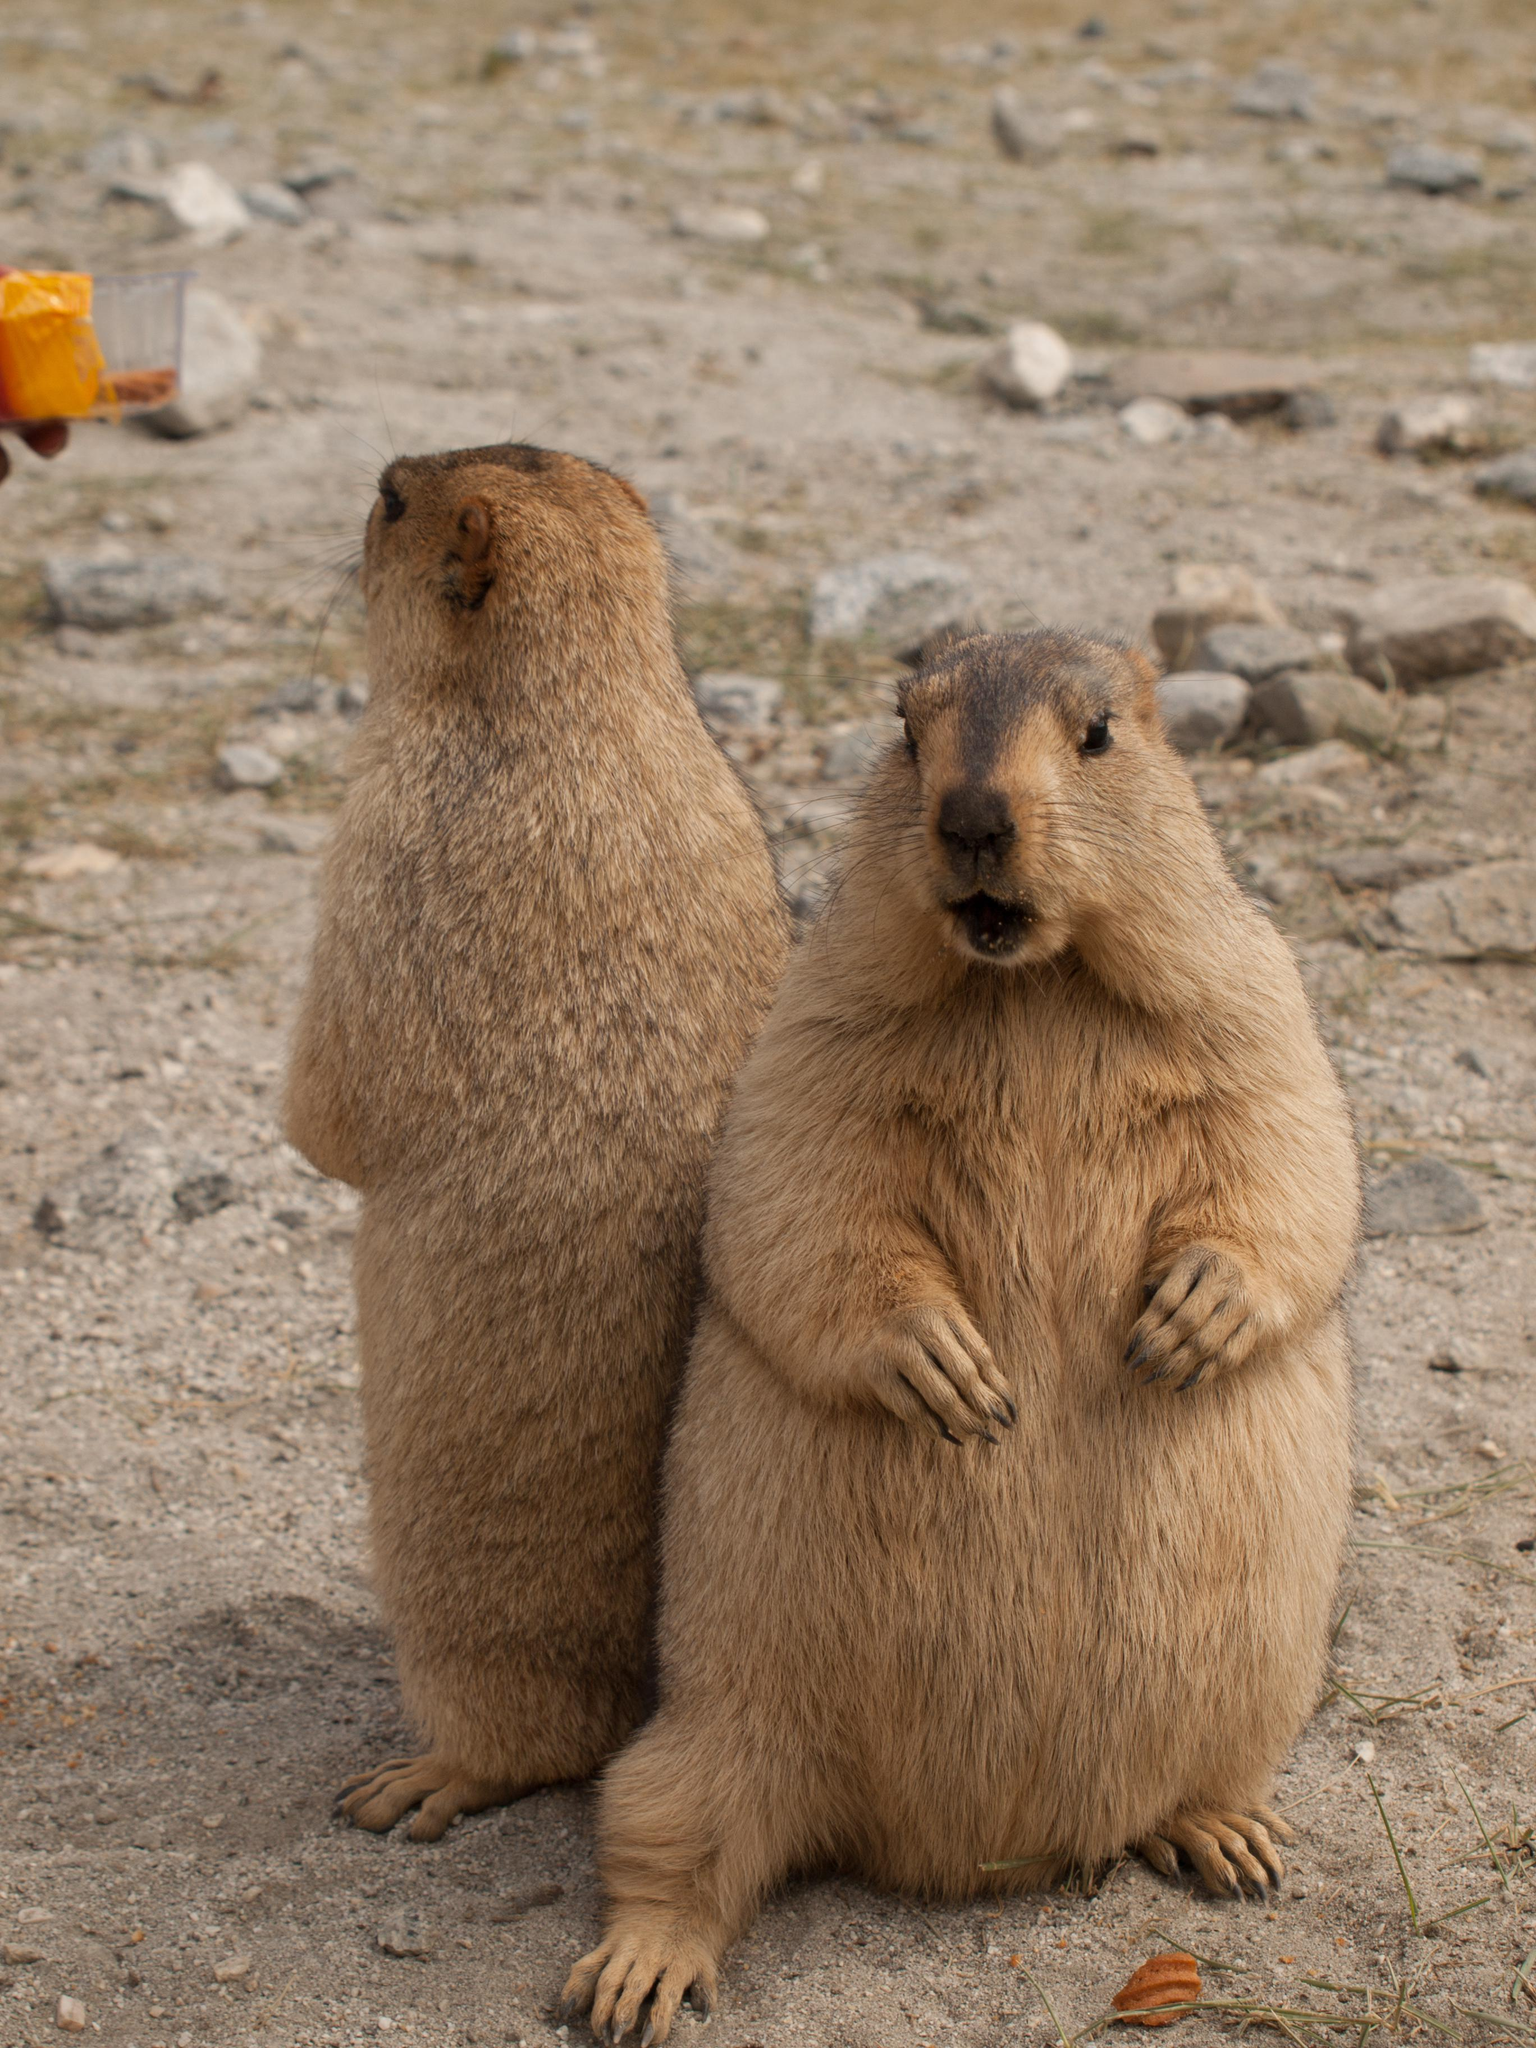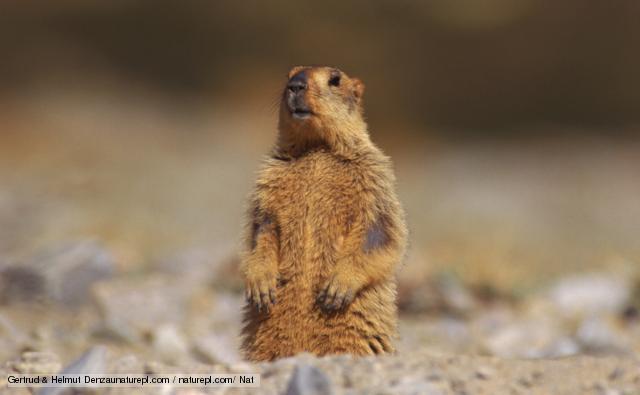The first image is the image on the left, the second image is the image on the right. Considering the images on both sides, is "At least one animal. Is standing on it's hind legs." valid? Answer yes or no. Yes. 